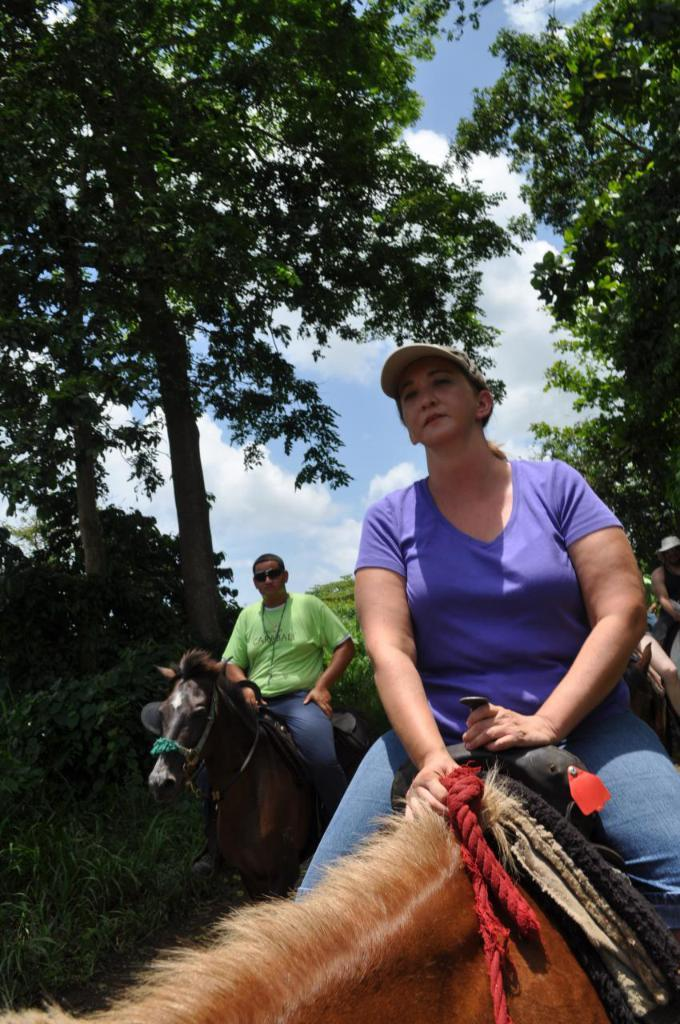What activity are the people in the image engaged in? The people in the image are horse riding. Can you describe the lady in the image? The lady in the image is wearing a cap and a purple t-shirt. What can be seen in the background of the image? There are trees in the background of the image. What is visible in the sky in the image? The sky is visible in the image, and it has clouds. How does the horse's digestion process work in the image? The image does not provide information about the horse's digestion process, so it cannot be determined from the image. 